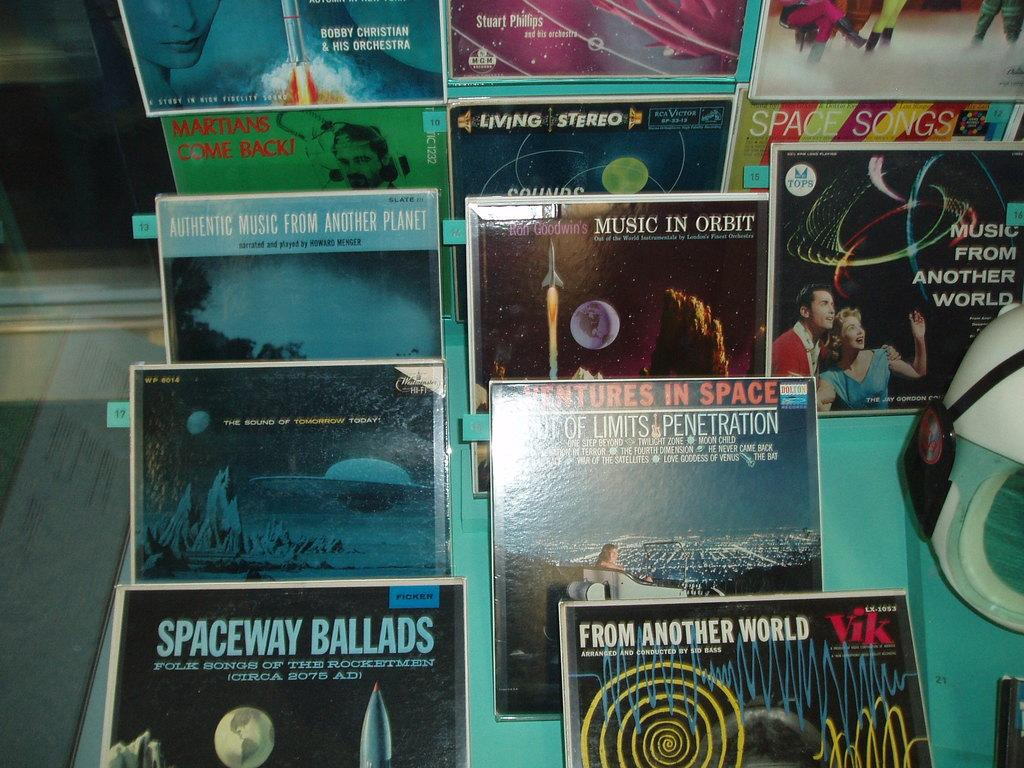<image>
Summarize the visual content of the image. Many records including Spaceway Ballads are on dispay. 